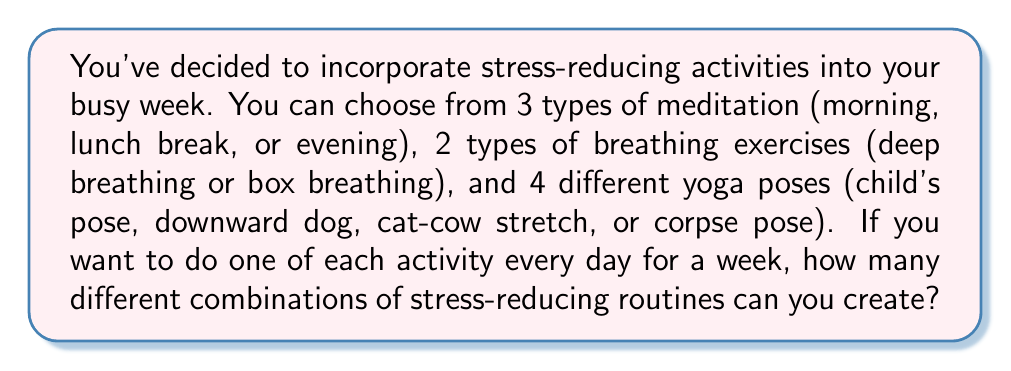Show me your answer to this math problem. Let's approach this step-by-step:

1) For each day, we need to choose:
   - 1 type of meditation
   - 1 type of breathing exercise
   - 1 yoga pose

2) According to the Multiplication Principle, if we have m ways of doing something, n ways of doing another thing, and p ways of doing a third thing, then there are m × n × p ways of doing all three things.

3) So, for each day:
   - We have 3 choices for meditation
   - We have 2 choices for breathing exercises
   - We have 4 choices for yoga poses

4) This means for each day, we have:

   $3 \times 2 \times 4 = 24$ possible combinations

5) Now, we need to do this for 7 days. Since each day's choices are independent of the other days, we again use the Multiplication Principle.

6) The total number of possible week-long routines is:

   $24^7 = (3 \times 2 \times 4)^7$

7) Calculating this:

   $24^7 = 4,586,471,424$

Therefore, there are 4,586,471,424 different possible week-long stress-reducing routines.
Answer: $4,586,471,424$ 